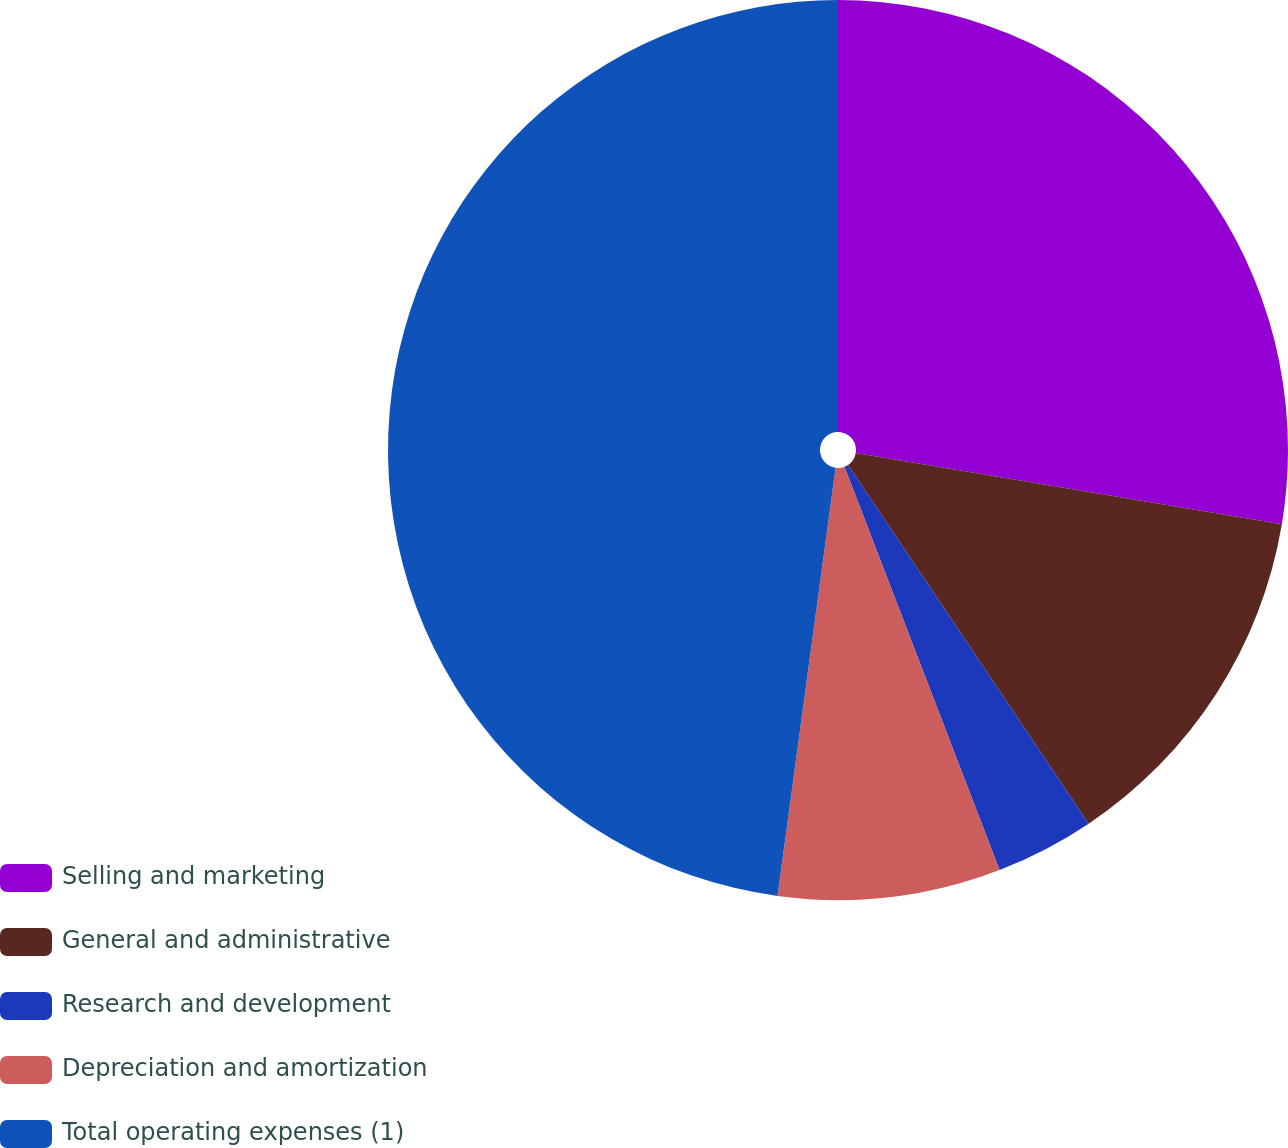Convert chart. <chart><loc_0><loc_0><loc_500><loc_500><pie_chart><fcel>Selling and marketing<fcel>General and administrative<fcel>Research and development<fcel>Depreciation and amortization<fcel>Total operating expenses (1)<nl><fcel>27.64%<fcel>12.96%<fcel>3.56%<fcel>7.99%<fcel>47.86%<nl></chart> 